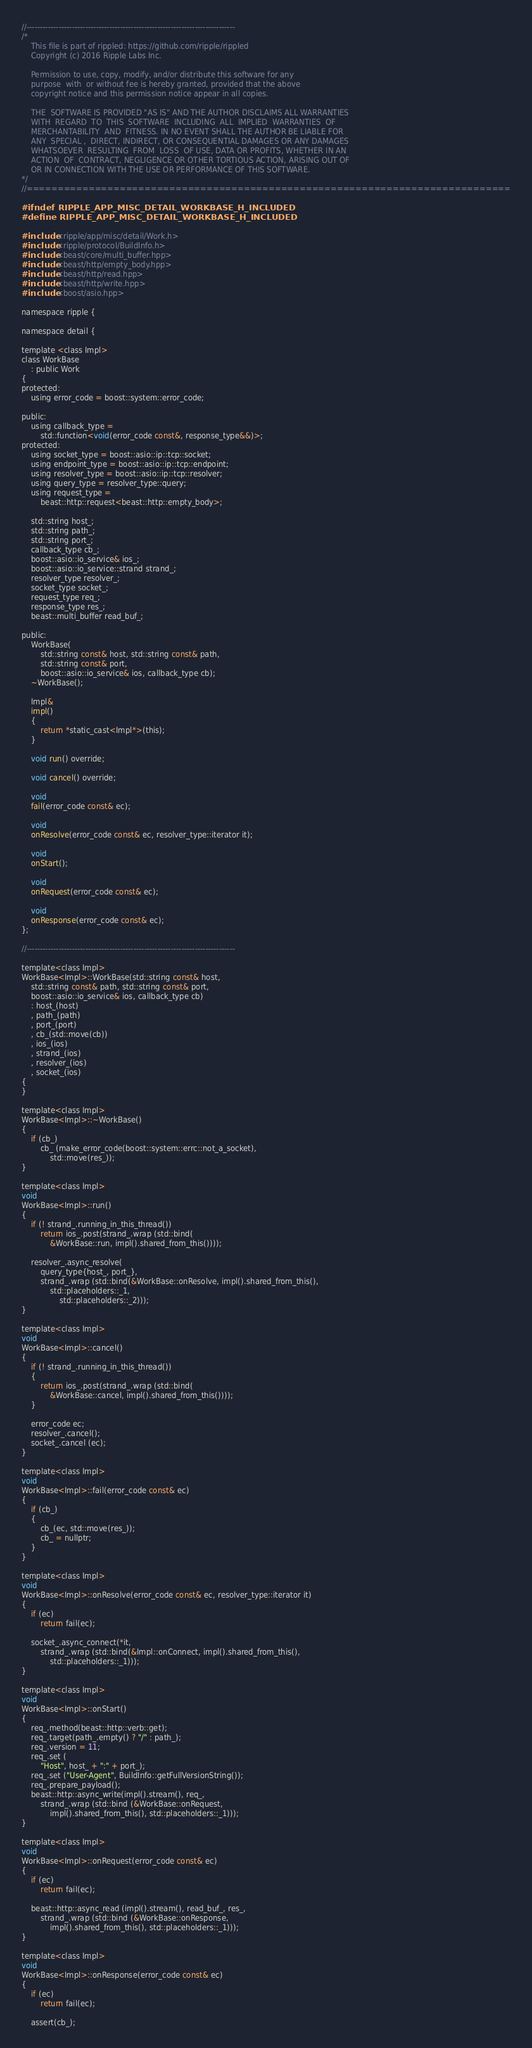<code> <loc_0><loc_0><loc_500><loc_500><_C_>//------------------------------------------------------------------------------
/*
    This file is part of rippled: https://github.com/ripple/rippled
    Copyright (c) 2016 Ripple Labs Inc.

    Permission to use, copy, modify, and/or distribute this software for any
    purpose  with  or without fee is hereby granted, provided that the above
    copyright notice and this permission notice appear in all copies.

    THE  SOFTWARE IS PROVIDED "AS IS" AND THE AUTHOR DISCLAIMS ALL WARRANTIES
    WITH  REGARD  TO  THIS  SOFTWARE  INCLUDING  ALL  IMPLIED  WARRANTIES  OF
    MERCHANTABILITY  AND  FITNESS. IN NO EVENT SHALL THE AUTHOR BE LIABLE FOR
    ANY  SPECIAL ,  DIRECT, INDIRECT, OR CONSEQUENTIAL DAMAGES OR ANY DAMAGES
    WHATSOEVER  RESULTING  FROM  LOSS  OF USE, DATA OR PROFITS, WHETHER IN AN
    ACTION  OF  CONTRACT, NEGLIGENCE OR OTHER TORTIOUS ACTION, ARISING OUT OF
    OR IN CONNECTION WITH THE USE OR PERFORMANCE OF THIS SOFTWARE.
*/
//==============================================================================

#ifndef RIPPLE_APP_MISC_DETAIL_WORKBASE_H_INCLUDED
#define RIPPLE_APP_MISC_DETAIL_WORKBASE_H_INCLUDED

#include <ripple/app/misc/detail/Work.h>
#include <ripple/protocol/BuildInfo.h>
#include <beast/core/multi_buffer.hpp>
#include <beast/http/empty_body.hpp>
#include <beast/http/read.hpp>
#include <beast/http/write.hpp>
#include <boost/asio.hpp>

namespace ripple {

namespace detail {

template <class Impl>
class WorkBase
    : public Work
{
protected:
    using error_code = boost::system::error_code;

public:
    using callback_type =
        std::function<void(error_code const&, response_type&&)>;
protected:
    using socket_type = boost::asio::ip::tcp::socket;
    using endpoint_type = boost::asio::ip::tcp::endpoint;
    using resolver_type = boost::asio::ip::tcp::resolver;
    using query_type = resolver_type::query;
    using request_type =
        beast::http::request<beast::http::empty_body>;

    std::string host_;
    std::string path_;
    std::string port_;
    callback_type cb_;
    boost::asio::io_service& ios_;
    boost::asio::io_service::strand strand_;
    resolver_type resolver_;
    socket_type socket_;
    request_type req_;
    response_type res_;
    beast::multi_buffer read_buf_;

public:
    WorkBase(
        std::string const& host, std::string const& path,
        std::string const& port,
        boost::asio::io_service& ios, callback_type cb);
    ~WorkBase();

    Impl&
    impl()
    {
        return *static_cast<Impl*>(this);
    }

    void run() override;

    void cancel() override;

    void
    fail(error_code const& ec);

    void
    onResolve(error_code const& ec, resolver_type::iterator it);

    void
    onStart();

    void
    onRequest(error_code const& ec);

    void
    onResponse(error_code const& ec);
};

//------------------------------------------------------------------------------

template<class Impl>
WorkBase<Impl>::WorkBase(std::string const& host,
    std::string const& path, std::string const& port,
    boost::asio::io_service& ios, callback_type cb)
    : host_(host)
    , path_(path)
    , port_(port)
    , cb_(std::move(cb))
    , ios_(ios)
    , strand_(ios)
    , resolver_(ios)
    , socket_(ios)
{
}

template<class Impl>
WorkBase<Impl>::~WorkBase()
{
    if (cb_)
        cb_ (make_error_code(boost::system::errc::not_a_socket),
            std::move(res_));
}

template<class Impl>
void
WorkBase<Impl>::run()
{
    if (! strand_.running_in_this_thread())
        return ios_.post(strand_.wrap (std::bind(
            &WorkBase::run, impl().shared_from_this())));

    resolver_.async_resolve(
        query_type{host_, port_},
        strand_.wrap (std::bind(&WorkBase::onResolve, impl().shared_from_this(),
            std::placeholders::_1,
                std::placeholders::_2)));
}

template<class Impl>
void
WorkBase<Impl>::cancel()
{
    if (! strand_.running_in_this_thread())
    {
        return ios_.post(strand_.wrap (std::bind(
            &WorkBase::cancel, impl().shared_from_this())));
    }

    error_code ec;
    resolver_.cancel();
    socket_.cancel (ec);
}

template<class Impl>
void
WorkBase<Impl>::fail(error_code const& ec)
{
    if (cb_)
    {
        cb_(ec, std::move(res_));
        cb_ = nullptr;
    }
}

template<class Impl>
void
WorkBase<Impl>::onResolve(error_code const& ec, resolver_type::iterator it)
{
    if (ec)
        return fail(ec);

    socket_.async_connect(*it,
        strand_.wrap (std::bind(&Impl::onConnect, impl().shared_from_this(),
            std::placeholders::_1)));
}

template<class Impl>
void
WorkBase<Impl>::onStart()
{
    req_.method(beast::http::verb::get);
    req_.target(path_.empty() ? "/" : path_);
    req_.version = 11;
    req_.set (
        "Host", host_ + ":" + port_);
    req_.set ("User-Agent", BuildInfo::getFullVersionString());
    req_.prepare_payload();
    beast::http::async_write(impl().stream(), req_,
        strand_.wrap (std::bind (&WorkBase::onRequest,
            impl().shared_from_this(), std::placeholders::_1)));
}

template<class Impl>
void
WorkBase<Impl>::onRequest(error_code const& ec)
{
    if (ec)
        return fail(ec);

    beast::http::async_read (impl().stream(), read_buf_, res_,
        strand_.wrap (std::bind (&WorkBase::onResponse,
            impl().shared_from_this(), std::placeholders::_1)));
}

template<class Impl>
void
WorkBase<Impl>::onResponse(error_code const& ec)
{
    if (ec)
        return fail(ec);

    assert(cb_);</code> 